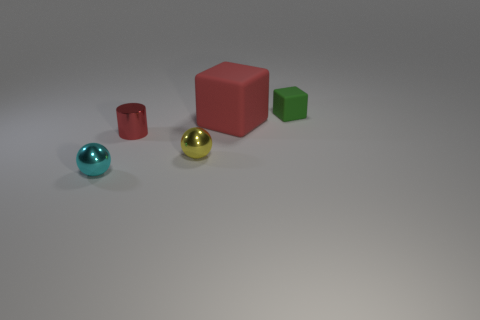What number of small red cylinders are there?
Offer a terse response. 1. There is a thing right of the rubber block that is to the left of the cube right of the red block; what shape is it?
Provide a short and direct response. Cube. Are there fewer objects that are in front of the red rubber block than tiny cyan metallic balls behind the small cyan metallic ball?
Offer a very short reply. No. Does the tiny red shiny object that is on the right side of the cyan object have the same shape as the rubber object on the left side of the small rubber object?
Ensure brevity in your answer.  No. What shape is the metallic thing that is in front of the metal sphere that is right of the tiny cyan metallic sphere?
Provide a succinct answer. Sphere. The matte object that is the same color as the tiny cylinder is what size?
Give a very brief answer. Large. Is there a small thing that has the same material as the tiny yellow ball?
Make the answer very short. Yes. There is a small object left of the cylinder; what material is it?
Your answer should be very brief. Metal. What is the material of the tiny green cube?
Your response must be concise. Rubber. Does the small ball on the right side of the small red metal object have the same material as the cyan object?
Make the answer very short. Yes. 